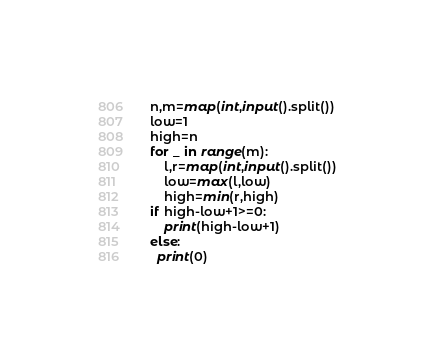<code> <loc_0><loc_0><loc_500><loc_500><_Python_>n,m=map(int,input().split())
low=1
high=n 
for _ in range(m):
    l,r=map(int,input().split())
    low=max(l,low)
    high=min(r,high)
if high-low+1>=0:
    print(high-low+1)
else:
  print(0)</code> 